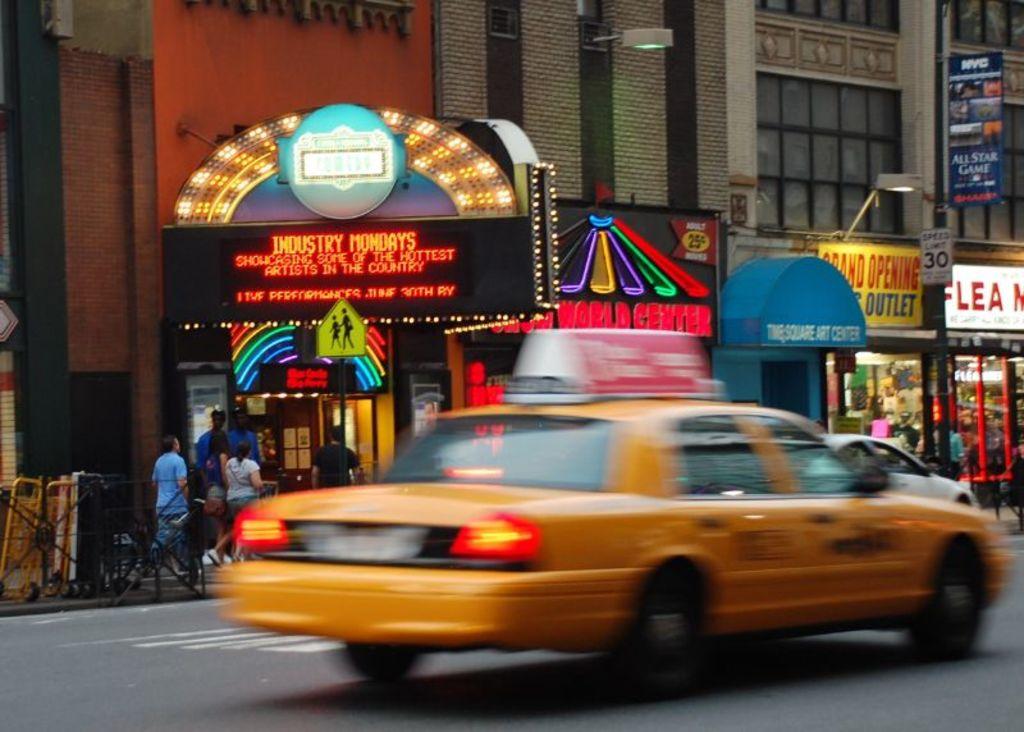What kind of monday is it?
Offer a very short reply. Industry. What is the speed limit on this street?
Offer a terse response. 30. 